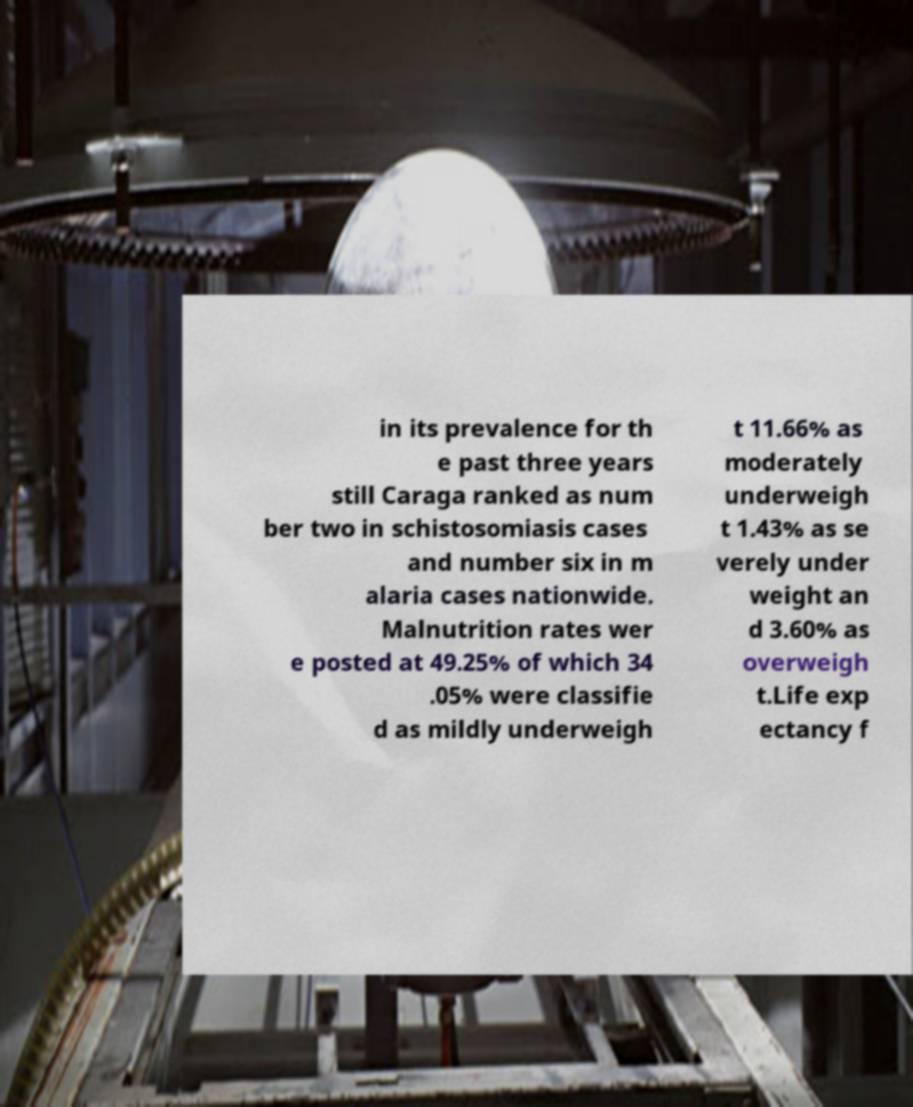For documentation purposes, I need the text within this image transcribed. Could you provide that? in its prevalence for th e past three years still Caraga ranked as num ber two in schistosomiasis cases and number six in m alaria cases nationwide. Malnutrition rates wer e posted at 49.25% of which 34 .05% were classifie d as mildly underweigh t 11.66% as moderately underweigh t 1.43% as se verely under weight an d 3.60% as overweigh t.Life exp ectancy f 